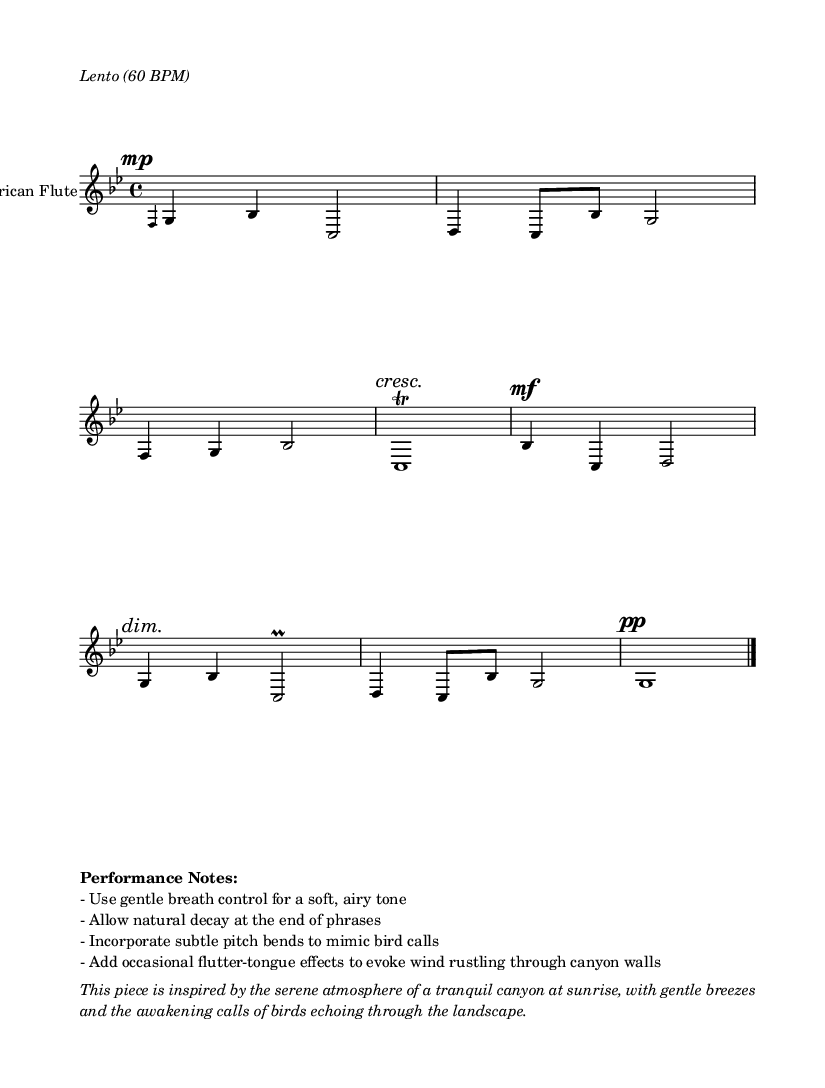What is the key signature of this music? The key signature has two flats, indicating it is in G minor. This is determined by counting the flats shown on the staff, which corresponds to G minor.
Answer: G minor What is the time signature of this piece? The time signature shown at the beginning is 4/4, which means there are four beats in each measure and the quarter note gets one beat. This is read directly from the time signature notation in the music.
Answer: 4/4 What is the tempo marking for this piece? The tempo is marked as "Lento (60 BPM)," which indicates a slow tempo of 60 beats per minute. This is indicated in the performance instructions at the beginning of the score.
Answer: Lento (60 BPM) What dynamic marking is indicated at the start of the piece? The dynamic marking at the start is "mp," which stands for mezzo-piano. This instruction is shown in the score at the beginning, directing the performer to play moderately soft.
Answer: mp At what point in the piece does a trill occur? The trill occurs at the measure where it is indicated next to a "c" note in the second section of the score. This is noted clearly in the music where the performer is instructed to add the trill to that note.
Answer: c1\trill What performance technique is suggested to mimic bird calls? The performance notes suggest incorporating "subtle pitch bends" to mimic bird calls, which enhance the natural sound of the Native American flute. This is detailed in the performance notes section at the bottom of the score.
Answer: subtle pitch bends What natural occurrence is this piece inspired by? The piece is inspired by the "tranquil canyon at sunrise," reflecting a serene atmosphere characterized by gentle breezes and bird calls. This inspiration is described in the program notes at the end of the score.
Answer: tranquil canyon at sunrise 